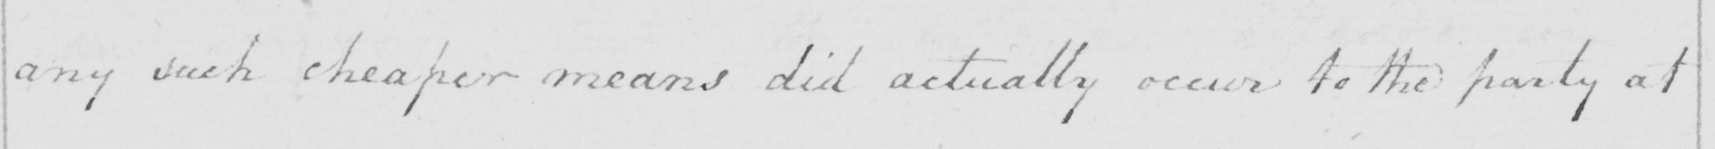What does this handwritten line say? any such cheaper means did actually occur to the party at 